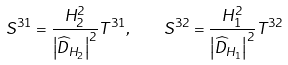Convert formula to latex. <formula><loc_0><loc_0><loc_500><loc_500>S ^ { 3 1 } = \frac { H _ { 2 } ^ { 2 } } { \left | \widehat { D } _ { H _ { 2 } } \right | ^ { 2 } } T ^ { 3 1 } , \quad S ^ { 3 2 } = \frac { H _ { 1 } ^ { 2 } } { \left | \widehat { D } _ { H _ { 1 } } \right | ^ { 2 } } T ^ { 3 2 }</formula> 